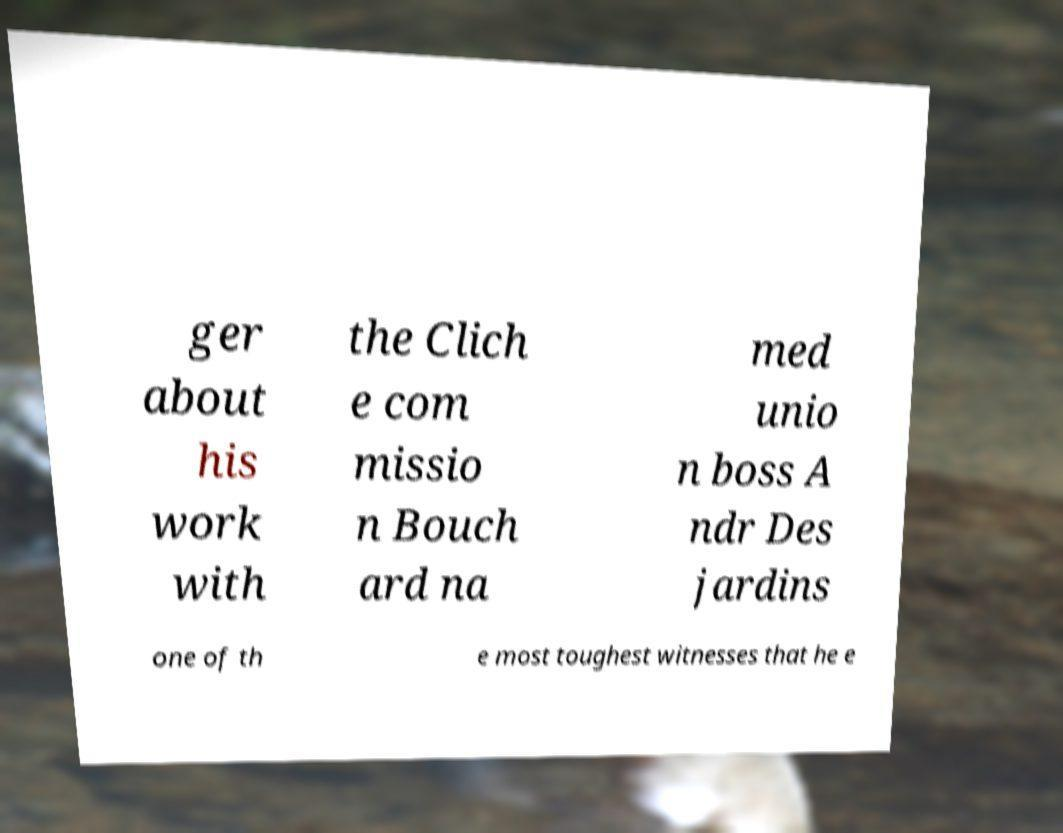Can you accurately transcribe the text from the provided image for me? ger about his work with the Clich e com missio n Bouch ard na med unio n boss A ndr Des jardins one of th e most toughest witnesses that he e 